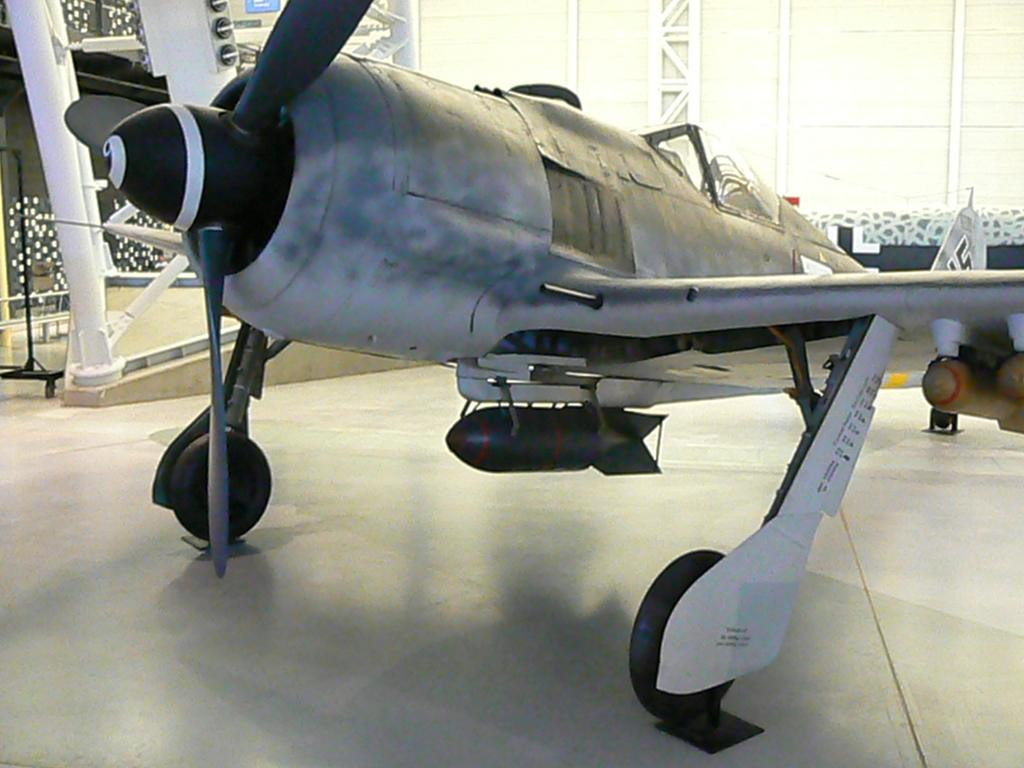What is placed on the floor in the image? There is an aircraft on the floor in the image. What can be seen in the background of the image? There is a wall and metal structures in the background of the image. Are there any visible light sources in the image? Yes, there are lights visible in the image. What type of linen is covering the aircraft in the image? There is no linen present in the image, and the aircraft is not covered. 